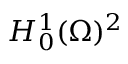<formula> <loc_0><loc_0><loc_500><loc_500>H _ { 0 } ^ { 1 } ( \Omega ) ^ { 2 }</formula> 